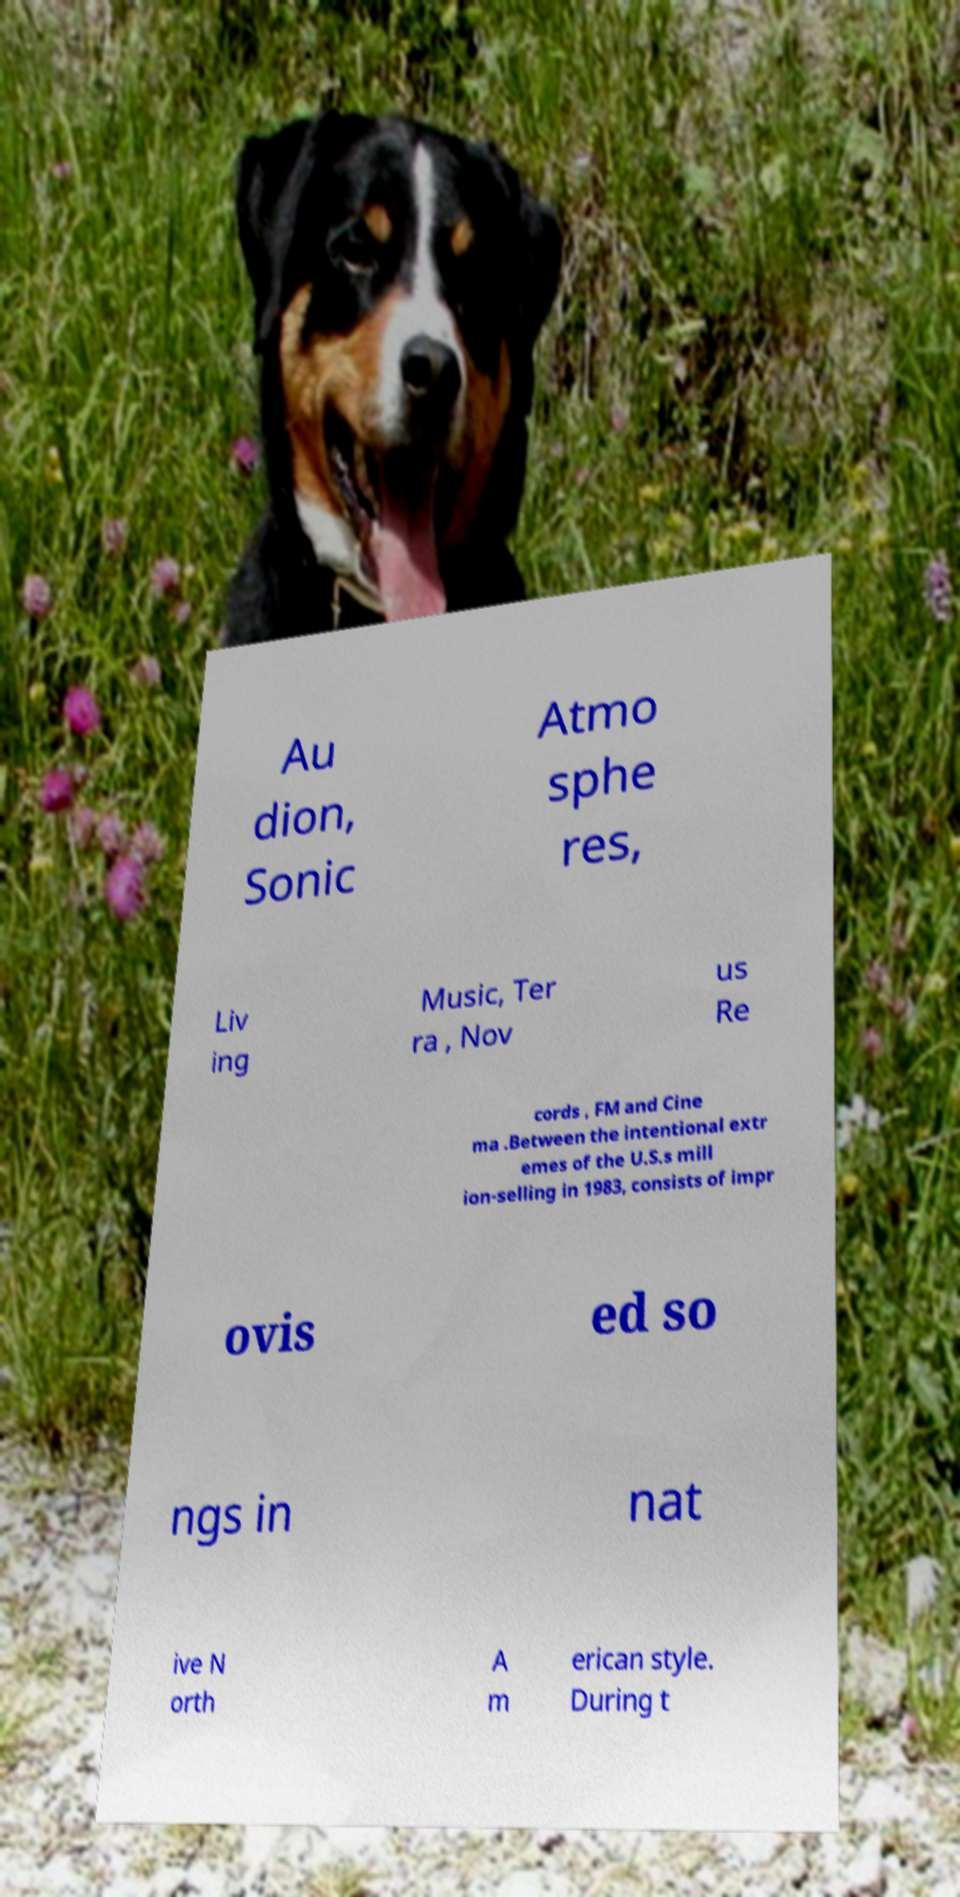Could you extract and type out the text from this image? Au dion, Sonic Atmo sphe res, Liv ing Music, Ter ra , Nov us Re cords , FM and Cine ma .Between the intentional extr emes of the U.S.s mill ion-selling in 1983, consists of impr ovis ed so ngs in nat ive N orth A m erican style. During t 